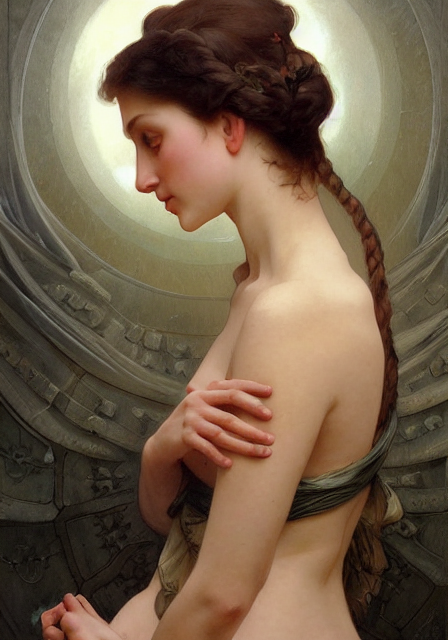What can be recognized in the background? The background features intricate and harmoniously arranged patterns that create the impression of a radiating halo behind the subject, providing a subtle contrast to the serenity of the figure. 